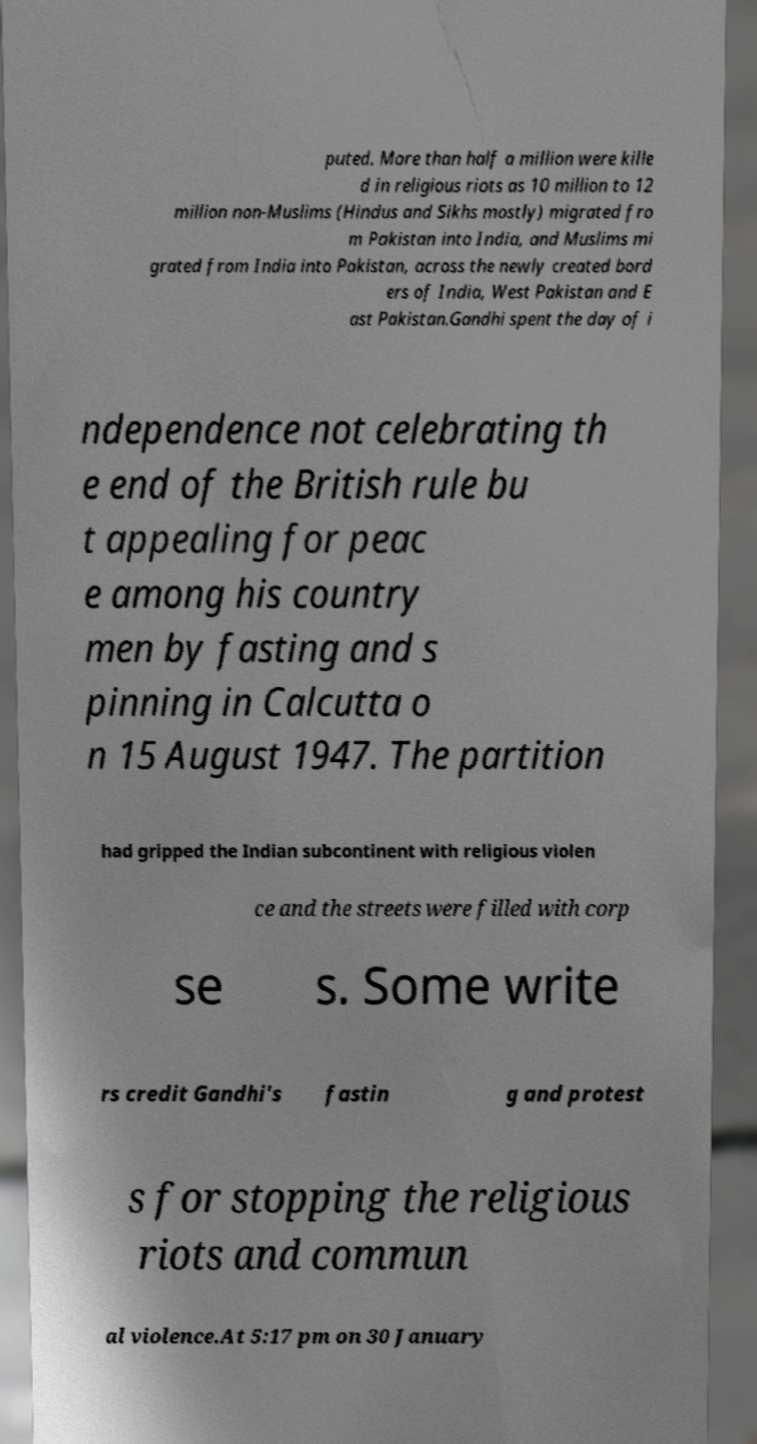There's text embedded in this image that I need extracted. Can you transcribe it verbatim? puted. More than half a million were kille d in religious riots as 10 million to 12 million non-Muslims (Hindus and Sikhs mostly) migrated fro m Pakistan into India, and Muslims mi grated from India into Pakistan, across the newly created bord ers of India, West Pakistan and E ast Pakistan.Gandhi spent the day of i ndependence not celebrating th e end of the British rule bu t appealing for peac e among his country men by fasting and s pinning in Calcutta o n 15 August 1947. The partition had gripped the Indian subcontinent with religious violen ce and the streets were filled with corp se s. Some write rs credit Gandhi's fastin g and protest s for stopping the religious riots and commun al violence.At 5:17 pm on 30 January 